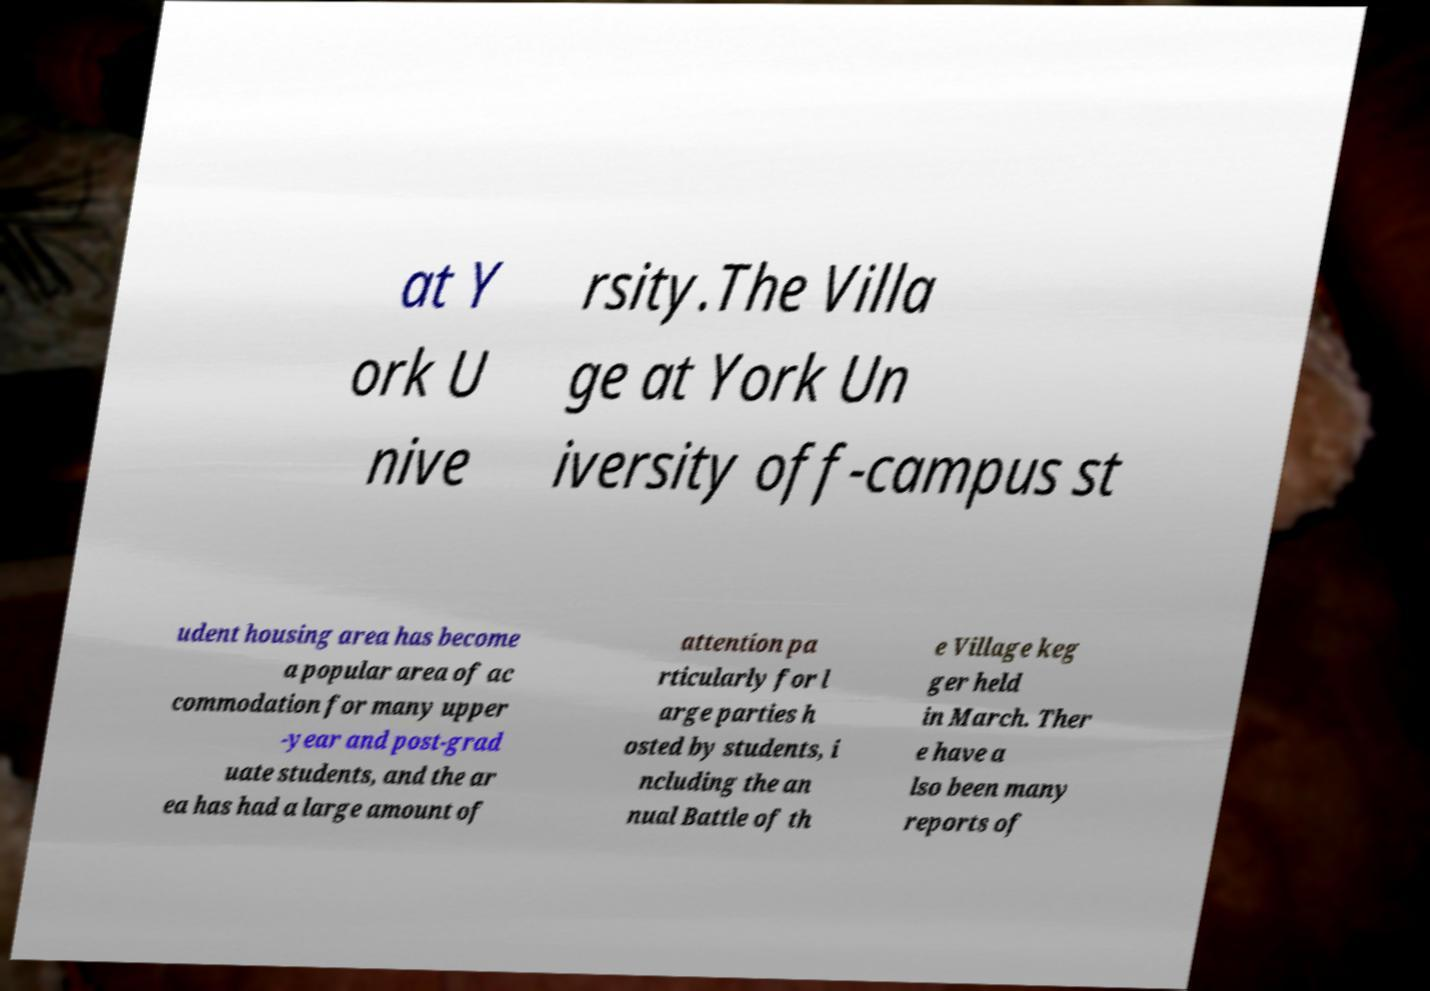Could you extract and type out the text from this image? at Y ork U nive rsity.The Villa ge at York Un iversity off-campus st udent housing area has become a popular area of ac commodation for many upper -year and post-grad uate students, and the ar ea has had a large amount of attention pa rticularly for l arge parties h osted by students, i ncluding the an nual Battle of th e Village keg ger held in March. Ther e have a lso been many reports of 